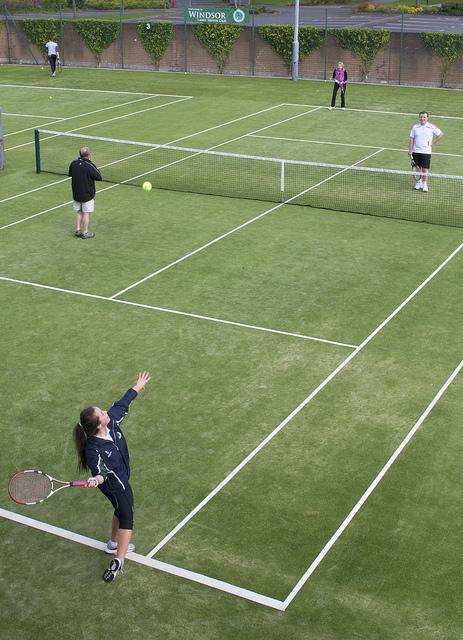What is about to get hit?
Be succinct. Ball. What is the game?
Answer briefly. Tennis. Could this be a practice session?
Be succinct. Yes. How many balls are on the ground?
Quick response, please. 0. What color is the tennis ball?
Give a very brief answer. Yellow. 